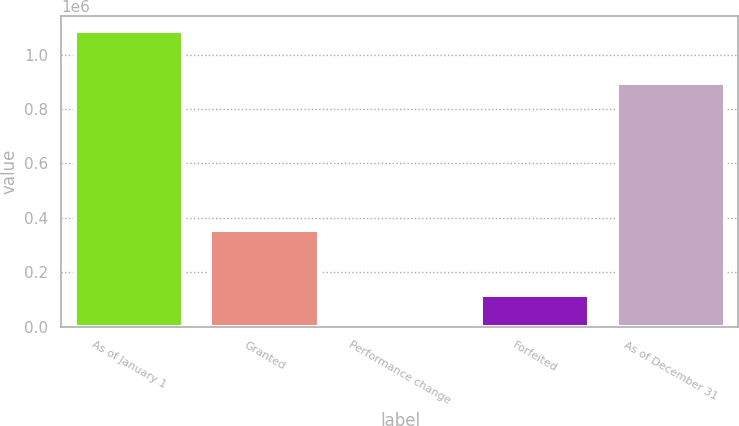<chart> <loc_0><loc_0><loc_500><loc_500><bar_chart><fcel>As of January 1<fcel>Granted<fcel>Performance change<fcel>Forfeited<fcel>As of December 31<nl><fcel>1.08908e+06<fcel>353734<fcel>6949<fcel>115162<fcel>895635<nl></chart> 